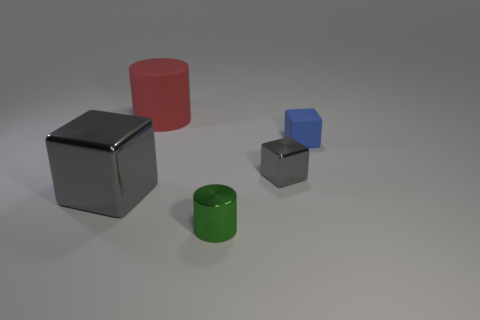Is the large object on the right side of the big shiny cube made of the same material as the big gray object?
Provide a short and direct response. No. What number of things are small red objects or rubber things behind the tiny blue rubber block?
Your response must be concise. 1. What number of big red objects are right of the large cylinder that is behind the tiny gray thing that is on the left side of the blue block?
Your response must be concise. 0. Does the rubber object in front of the matte cylinder have the same shape as the small gray shiny object?
Provide a short and direct response. Yes. There is a gray cube on the left side of the green metallic cylinder; are there any red cylinders to the right of it?
Your answer should be compact. Yes. How many cyan spheres are there?
Ensure brevity in your answer.  0. There is a metal thing that is both in front of the tiny gray thing and behind the tiny green cylinder; what color is it?
Ensure brevity in your answer.  Gray. What size is the other thing that is the same shape as the red matte thing?
Make the answer very short. Small. What number of gray cubes have the same size as the blue rubber object?
Ensure brevity in your answer.  1. What material is the large red thing?
Offer a very short reply. Rubber. 